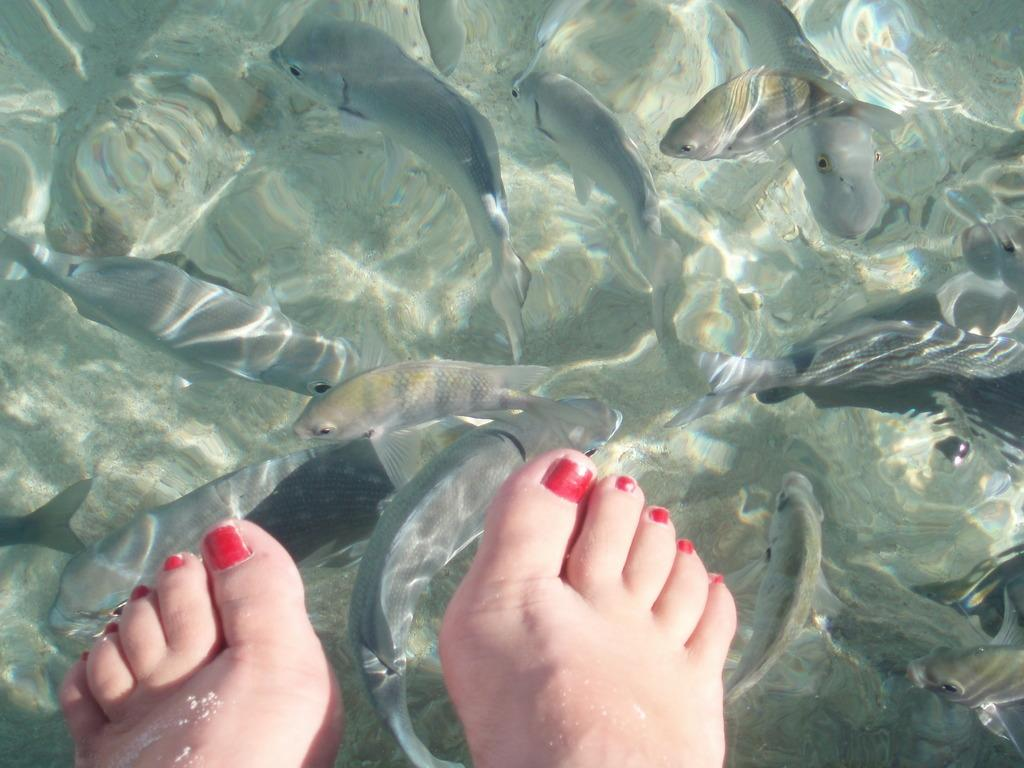What part of a person can be seen in the image? There are legs of a person visible in the image. What is present in the water in the image? There are fishes in the water in the image. What type of hall can be seen in the image? There is no hall present in the image; it features legs of a person and fishes in the water. What impulse might the person be experiencing while standing in the image? There is no information about the person's emotions or impulses in the image, so it cannot be determined. 